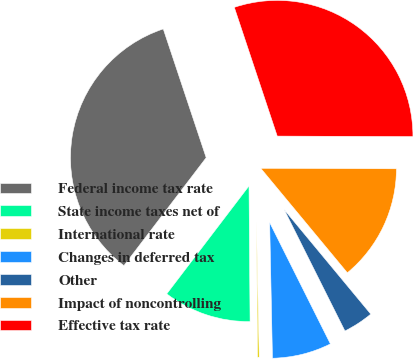<chart> <loc_0><loc_0><loc_500><loc_500><pie_chart><fcel>Federal income tax rate<fcel>State income taxes net of<fcel>International rate<fcel>Changes in deferred tax<fcel>Other<fcel>Impact of noncontrolling<fcel>Effective tax rate<nl><fcel>34.52%<fcel>10.49%<fcel>0.2%<fcel>7.06%<fcel>3.63%<fcel>13.93%<fcel>30.18%<nl></chart> 